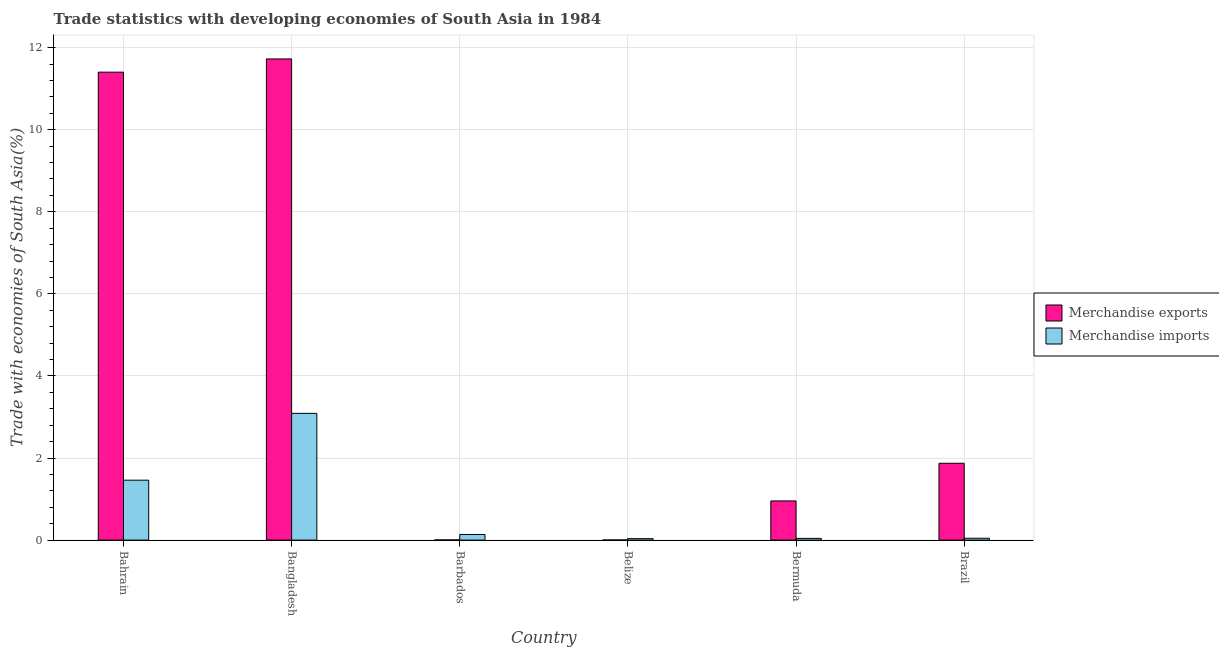How many different coloured bars are there?
Your answer should be compact. 2. How many groups of bars are there?
Your response must be concise. 6. How many bars are there on the 1st tick from the left?
Ensure brevity in your answer.  2. What is the label of the 6th group of bars from the left?
Offer a terse response. Brazil. In how many cases, is the number of bars for a given country not equal to the number of legend labels?
Provide a short and direct response. 0. What is the merchandise imports in Brazil?
Your answer should be very brief. 0.05. Across all countries, what is the maximum merchandise imports?
Make the answer very short. 3.09. Across all countries, what is the minimum merchandise imports?
Ensure brevity in your answer.  0.04. In which country was the merchandise imports minimum?
Give a very brief answer. Belize. What is the total merchandise imports in the graph?
Provide a short and direct response. 4.81. What is the difference between the merchandise imports in Barbados and that in Belize?
Make the answer very short. 0.1. What is the difference between the merchandise imports in Bangladesh and the merchandise exports in Barbados?
Your answer should be compact. 3.08. What is the average merchandise imports per country?
Ensure brevity in your answer.  0.8. What is the difference between the merchandise exports and merchandise imports in Bermuda?
Your response must be concise. 0.91. In how many countries, is the merchandise imports greater than 4 %?
Your answer should be very brief. 0. What is the ratio of the merchandise imports in Bahrain to that in Barbados?
Offer a terse response. 10.69. What is the difference between the highest and the second highest merchandise imports?
Your answer should be very brief. 1.63. What is the difference between the highest and the lowest merchandise exports?
Ensure brevity in your answer.  11.72. In how many countries, is the merchandise imports greater than the average merchandise imports taken over all countries?
Give a very brief answer. 2. Is the sum of the merchandise imports in Bangladesh and Brazil greater than the maximum merchandise exports across all countries?
Your answer should be very brief. No. What does the 2nd bar from the left in Barbados represents?
Ensure brevity in your answer.  Merchandise imports. What does the 1st bar from the right in Barbados represents?
Provide a succinct answer. Merchandise imports. How many bars are there?
Your answer should be compact. 12. How many countries are there in the graph?
Ensure brevity in your answer.  6. What is the difference between two consecutive major ticks on the Y-axis?
Ensure brevity in your answer.  2. Are the values on the major ticks of Y-axis written in scientific E-notation?
Your answer should be very brief. No. Where does the legend appear in the graph?
Your answer should be compact. Center right. How many legend labels are there?
Provide a short and direct response. 2. What is the title of the graph?
Your answer should be very brief. Trade statistics with developing economies of South Asia in 1984. What is the label or title of the X-axis?
Your answer should be compact. Country. What is the label or title of the Y-axis?
Make the answer very short. Trade with economies of South Asia(%). What is the Trade with economies of South Asia(%) of Merchandise exports in Bahrain?
Give a very brief answer. 11.4. What is the Trade with economies of South Asia(%) in Merchandise imports in Bahrain?
Make the answer very short. 1.46. What is the Trade with economies of South Asia(%) in Merchandise exports in Bangladesh?
Your answer should be compact. 11.72. What is the Trade with economies of South Asia(%) of Merchandise imports in Bangladesh?
Your answer should be compact. 3.09. What is the Trade with economies of South Asia(%) in Merchandise exports in Barbados?
Offer a terse response. 0. What is the Trade with economies of South Asia(%) in Merchandise imports in Barbados?
Make the answer very short. 0.14. What is the Trade with economies of South Asia(%) of Merchandise exports in Belize?
Your answer should be very brief. 0. What is the Trade with economies of South Asia(%) of Merchandise imports in Belize?
Provide a short and direct response. 0.04. What is the Trade with economies of South Asia(%) in Merchandise exports in Bermuda?
Make the answer very short. 0.95. What is the Trade with economies of South Asia(%) in Merchandise imports in Bermuda?
Give a very brief answer. 0.04. What is the Trade with economies of South Asia(%) in Merchandise exports in Brazil?
Ensure brevity in your answer.  1.87. What is the Trade with economies of South Asia(%) of Merchandise imports in Brazil?
Give a very brief answer. 0.05. Across all countries, what is the maximum Trade with economies of South Asia(%) of Merchandise exports?
Your answer should be very brief. 11.72. Across all countries, what is the maximum Trade with economies of South Asia(%) of Merchandise imports?
Your answer should be compact. 3.09. Across all countries, what is the minimum Trade with economies of South Asia(%) of Merchandise exports?
Offer a terse response. 0. Across all countries, what is the minimum Trade with economies of South Asia(%) in Merchandise imports?
Provide a succinct answer. 0.04. What is the total Trade with economies of South Asia(%) of Merchandise exports in the graph?
Give a very brief answer. 25.96. What is the total Trade with economies of South Asia(%) of Merchandise imports in the graph?
Offer a very short reply. 4.81. What is the difference between the Trade with economies of South Asia(%) in Merchandise exports in Bahrain and that in Bangladesh?
Keep it short and to the point. -0.32. What is the difference between the Trade with economies of South Asia(%) in Merchandise imports in Bahrain and that in Bangladesh?
Ensure brevity in your answer.  -1.63. What is the difference between the Trade with economies of South Asia(%) of Merchandise exports in Bahrain and that in Barbados?
Provide a succinct answer. 11.4. What is the difference between the Trade with economies of South Asia(%) of Merchandise imports in Bahrain and that in Barbados?
Offer a terse response. 1.32. What is the difference between the Trade with economies of South Asia(%) in Merchandise exports in Bahrain and that in Belize?
Your answer should be very brief. 11.4. What is the difference between the Trade with economies of South Asia(%) of Merchandise imports in Bahrain and that in Belize?
Offer a very short reply. 1.42. What is the difference between the Trade with economies of South Asia(%) in Merchandise exports in Bahrain and that in Bermuda?
Offer a very short reply. 10.45. What is the difference between the Trade with economies of South Asia(%) of Merchandise imports in Bahrain and that in Bermuda?
Provide a succinct answer. 1.42. What is the difference between the Trade with economies of South Asia(%) of Merchandise exports in Bahrain and that in Brazil?
Your answer should be compact. 9.53. What is the difference between the Trade with economies of South Asia(%) in Merchandise imports in Bahrain and that in Brazil?
Provide a short and direct response. 1.42. What is the difference between the Trade with economies of South Asia(%) in Merchandise exports in Bangladesh and that in Barbados?
Make the answer very short. 11.72. What is the difference between the Trade with economies of South Asia(%) of Merchandise imports in Bangladesh and that in Barbados?
Provide a short and direct response. 2.95. What is the difference between the Trade with economies of South Asia(%) in Merchandise exports in Bangladesh and that in Belize?
Provide a short and direct response. 11.72. What is the difference between the Trade with economies of South Asia(%) of Merchandise imports in Bangladesh and that in Belize?
Provide a succinct answer. 3.05. What is the difference between the Trade with economies of South Asia(%) in Merchandise exports in Bangladesh and that in Bermuda?
Your answer should be very brief. 10.77. What is the difference between the Trade with economies of South Asia(%) in Merchandise imports in Bangladesh and that in Bermuda?
Make the answer very short. 3.05. What is the difference between the Trade with economies of South Asia(%) of Merchandise exports in Bangladesh and that in Brazil?
Ensure brevity in your answer.  9.85. What is the difference between the Trade with economies of South Asia(%) of Merchandise imports in Bangladesh and that in Brazil?
Offer a very short reply. 3.04. What is the difference between the Trade with economies of South Asia(%) in Merchandise exports in Barbados and that in Belize?
Offer a very short reply. 0. What is the difference between the Trade with economies of South Asia(%) in Merchandise imports in Barbados and that in Belize?
Ensure brevity in your answer.  0.1. What is the difference between the Trade with economies of South Asia(%) of Merchandise exports in Barbados and that in Bermuda?
Provide a short and direct response. -0.95. What is the difference between the Trade with economies of South Asia(%) of Merchandise imports in Barbados and that in Bermuda?
Your answer should be compact. 0.09. What is the difference between the Trade with economies of South Asia(%) in Merchandise exports in Barbados and that in Brazil?
Provide a succinct answer. -1.87. What is the difference between the Trade with economies of South Asia(%) of Merchandise imports in Barbados and that in Brazil?
Your response must be concise. 0.09. What is the difference between the Trade with economies of South Asia(%) of Merchandise exports in Belize and that in Bermuda?
Your answer should be very brief. -0.95. What is the difference between the Trade with economies of South Asia(%) of Merchandise imports in Belize and that in Bermuda?
Your answer should be very brief. -0.01. What is the difference between the Trade with economies of South Asia(%) of Merchandise exports in Belize and that in Brazil?
Give a very brief answer. -1.87. What is the difference between the Trade with economies of South Asia(%) in Merchandise imports in Belize and that in Brazil?
Offer a terse response. -0.01. What is the difference between the Trade with economies of South Asia(%) of Merchandise exports in Bermuda and that in Brazil?
Your answer should be very brief. -0.92. What is the difference between the Trade with economies of South Asia(%) in Merchandise imports in Bermuda and that in Brazil?
Give a very brief answer. -0. What is the difference between the Trade with economies of South Asia(%) in Merchandise exports in Bahrain and the Trade with economies of South Asia(%) in Merchandise imports in Bangladesh?
Keep it short and to the point. 8.31. What is the difference between the Trade with economies of South Asia(%) of Merchandise exports in Bahrain and the Trade with economies of South Asia(%) of Merchandise imports in Barbados?
Your answer should be very brief. 11.27. What is the difference between the Trade with economies of South Asia(%) of Merchandise exports in Bahrain and the Trade with economies of South Asia(%) of Merchandise imports in Belize?
Make the answer very short. 11.37. What is the difference between the Trade with economies of South Asia(%) of Merchandise exports in Bahrain and the Trade with economies of South Asia(%) of Merchandise imports in Bermuda?
Offer a very short reply. 11.36. What is the difference between the Trade with economies of South Asia(%) in Merchandise exports in Bahrain and the Trade with economies of South Asia(%) in Merchandise imports in Brazil?
Ensure brevity in your answer.  11.36. What is the difference between the Trade with economies of South Asia(%) in Merchandise exports in Bangladesh and the Trade with economies of South Asia(%) in Merchandise imports in Barbados?
Provide a succinct answer. 11.59. What is the difference between the Trade with economies of South Asia(%) of Merchandise exports in Bangladesh and the Trade with economies of South Asia(%) of Merchandise imports in Belize?
Ensure brevity in your answer.  11.69. What is the difference between the Trade with economies of South Asia(%) in Merchandise exports in Bangladesh and the Trade with economies of South Asia(%) in Merchandise imports in Bermuda?
Your answer should be compact. 11.68. What is the difference between the Trade with economies of South Asia(%) in Merchandise exports in Bangladesh and the Trade with economies of South Asia(%) in Merchandise imports in Brazil?
Provide a succinct answer. 11.68. What is the difference between the Trade with economies of South Asia(%) of Merchandise exports in Barbados and the Trade with economies of South Asia(%) of Merchandise imports in Belize?
Offer a very short reply. -0.03. What is the difference between the Trade with economies of South Asia(%) of Merchandise exports in Barbados and the Trade with economies of South Asia(%) of Merchandise imports in Bermuda?
Offer a terse response. -0.04. What is the difference between the Trade with economies of South Asia(%) of Merchandise exports in Barbados and the Trade with economies of South Asia(%) of Merchandise imports in Brazil?
Offer a very short reply. -0.04. What is the difference between the Trade with economies of South Asia(%) of Merchandise exports in Belize and the Trade with economies of South Asia(%) of Merchandise imports in Bermuda?
Offer a terse response. -0.04. What is the difference between the Trade with economies of South Asia(%) of Merchandise exports in Belize and the Trade with economies of South Asia(%) of Merchandise imports in Brazil?
Your answer should be compact. -0.04. What is the difference between the Trade with economies of South Asia(%) of Merchandise exports in Bermuda and the Trade with economies of South Asia(%) of Merchandise imports in Brazil?
Offer a very short reply. 0.91. What is the average Trade with economies of South Asia(%) of Merchandise exports per country?
Your response must be concise. 4.33. What is the average Trade with economies of South Asia(%) in Merchandise imports per country?
Give a very brief answer. 0.8. What is the difference between the Trade with economies of South Asia(%) of Merchandise exports and Trade with economies of South Asia(%) of Merchandise imports in Bahrain?
Ensure brevity in your answer.  9.94. What is the difference between the Trade with economies of South Asia(%) in Merchandise exports and Trade with economies of South Asia(%) in Merchandise imports in Bangladesh?
Ensure brevity in your answer.  8.64. What is the difference between the Trade with economies of South Asia(%) of Merchandise exports and Trade with economies of South Asia(%) of Merchandise imports in Barbados?
Provide a succinct answer. -0.13. What is the difference between the Trade with economies of South Asia(%) of Merchandise exports and Trade with economies of South Asia(%) of Merchandise imports in Belize?
Ensure brevity in your answer.  -0.03. What is the difference between the Trade with economies of South Asia(%) of Merchandise exports and Trade with economies of South Asia(%) of Merchandise imports in Bermuda?
Your response must be concise. 0.91. What is the difference between the Trade with economies of South Asia(%) of Merchandise exports and Trade with economies of South Asia(%) of Merchandise imports in Brazil?
Provide a short and direct response. 1.83. What is the ratio of the Trade with economies of South Asia(%) of Merchandise exports in Bahrain to that in Bangladesh?
Provide a short and direct response. 0.97. What is the ratio of the Trade with economies of South Asia(%) of Merchandise imports in Bahrain to that in Bangladesh?
Your answer should be compact. 0.47. What is the ratio of the Trade with economies of South Asia(%) in Merchandise exports in Bahrain to that in Barbados?
Your response must be concise. 2613.7. What is the ratio of the Trade with economies of South Asia(%) of Merchandise imports in Bahrain to that in Barbados?
Your response must be concise. 10.69. What is the ratio of the Trade with economies of South Asia(%) in Merchandise exports in Bahrain to that in Belize?
Provide a succinct answer. 3542.62. What is the ratio of the Trade with economies of South Asia(%) of Merchandise imports in Bahrain to that in Belize?
Your response must be concise. 41.26. What is the ratio of the Trade with economies of South Asia(%) of Merchandise exports in Bahrain to that in Bermuda?
Give a very brief answer. 11.94. What is the ratio of the Trade with economies of South Asia(%) in Merchandise imports in Bahrain to that in Bermuda?
Make the answer very short. 34.82. What is the ratio of the Trade with economies of South Asia(%) in Merchandise exports in Bahrain to that in Brazil?
Keep it short and to the point. 6.09. What is the ratio of the Trade with economies of South Asia(%) in Merchandise imports in Bahrain to that in Brazil?
Your answer should be compact. 32.33. What is the ratio of the Trade with economies of South Asia(%) in Merchandise exports in Bangladesh to that in Barbados?
Provide a short and direct response. 2687.51. What is the ratio of the Trade with economies of South Asia(%) in Merchandise imports in Bangladesh to that in Barbados?
Your response must be concise. 22.62. What is the ratio of the Trade with economies of South Asia(%) of Merchandise exports in Bangladesh to that in Belize?
Keep it short and to the point. 3642.66. What is the ratio of the Trade with economies of South Asia(%) in Merchandise imports in Bangladesh to that in Belize?
Your answer should be compact. 87.25. What is the ratio of the Trade with economies of South Asia(%) in Merchandise exports in Bangladesh to that in Bermuda?
Make the answer very short. 12.28. What is the ratio of the Trade with economies of South Asia(%) in Merchandise imports in Bangladesh to that in Bermuda?
Ensure brevity in your answer.  73.64. What is the ratio of the Trade with economies of South Asia(%) of Merchandise exports in Bangladesh to that in Brazil?
Give a very brief answer. 6.26. What is the ratio of the Trade with economies of South Asia(%) of Merchandise imports in Bangladesh to that in Brazil?
Your answer should be compact. 68.37. What is the ratio of the Trade with economies of South Asia(%) of Merchandise exports in Barbados to that in Belize?
Ensure brevity in your answer.  1.36. What is the ratio of the Trade with economies of South Asia(%) in Merchandise imports in Barbados to that in Belize?
Provide a short and direct response. 3.86. What is the ratio of the Trade with economies of South Asia(%) of Merchandise exports in Barbados to that in Bermuda?
Keep it short and to the point. 0. What is the ratio of the Trade with economies of South Asia(%) in Merchandise imports in Barbados to that in Bermuda?
Ensure brevity in your answer.  3.26. What is the ratio of the Trade with economies of South Asia(%) in Merchandise exports in Barbados to that in Brazil?
Keep it short and to the point. 0. What is the ratio of the Trade with economies of South Asia(%) in Merchandise imports in Barbados to that in Brazil?
Offer a terse response. 3.02. What is the ratio of the Trade with economies of South Asia(%) of Merchandise exports in Belize to that in Bermuda?
Ensure brevity in your answer.  0. What is the ratio of the Trade with economies of South Asia(%) of Merchandise imports in Belize to that in Bermuda?
Offer a very short reply. 0.84. What is the ratio of the Trade with economies of South Asia(%) in Merchandise exports in Belize to that in Brazil?
Your answer should be compact. 0. What is the ratio of the Trade with economies of South Asia(%) in Merchandise imports in Belize to that in Brazil?
Make the answer very short. 0.78. What is the ratio of the Trade with economies of South Asia(%) in Merchandise exports in Bermuda to that in Brazil?
Give a very brief answer. 0.51. What is the ratio of the Trade with economies of South Asia(%) in Merchandise imports in Bermuda to that in Brazil?
Your answer should be compact. 0.93. What is the difference between the highest and the second highest Trade with economies of South Asia(%) of Merchandise exports?
Make the answer very short. 0.32. What is the difference between the highest and the second highest Trade with economies of South Asia(%) of Merchandise imports?
Your response must be concise. 1.63. What is the difference between the highest and the lowest Trade with economies of South Asia(%) in Merchandise exports?
Give a very brief answer. 11.72. What is the difference between the highest and the lowest Trade with economies of South Asia(%) of Merchandise imports?
Your response must be concise. 3.05. 